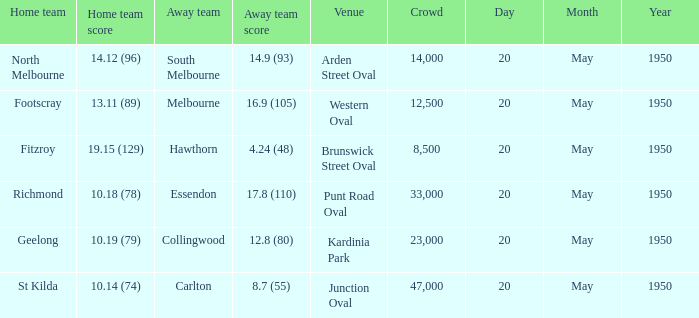What was the date of the game when the away team was south melbourne? 20 May 1950. 